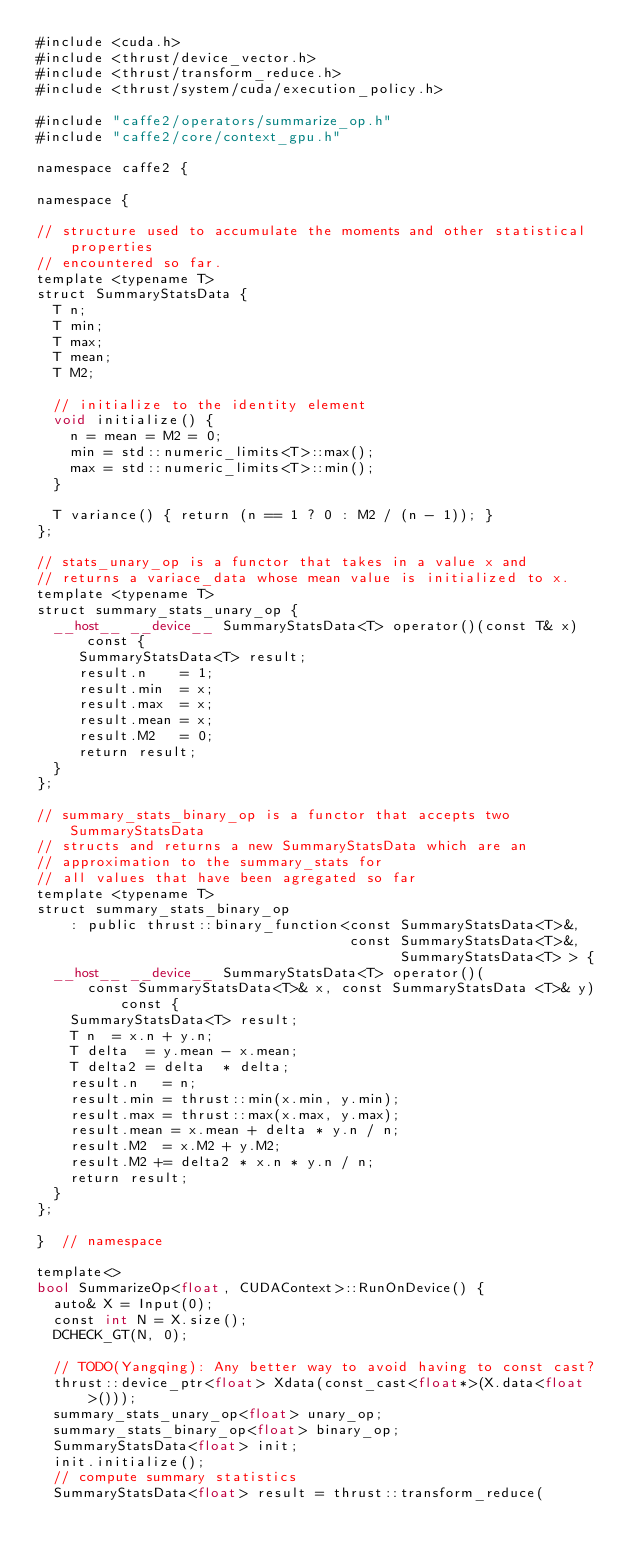<code> <loc_0><loc_0><loc_500><loc_500><_Cuda_>#include <cuda.h>
#include <thrust/device_vector.h>
#include <thrust/transform_reduce.h>
#include <thrust/system/cuda/execution_policy.h>

#include "caffe2/operators/summarize_op.h"
#include "caffe2/core/context_gpu.h"

namespace caffe2 {

namespace {

// structure used to accumulate the moments and other statistical properties
// encountered so far.
template <typename T>
struct SummaryStatsData {
  T n;
  T min;
  T max;
  T mean;
  T M2;

  // initialize to the identity element
  void initialize() {
    n = mean = M2 = 0;
    min = std::numeric_limits<T>::max();
    max = std::numeric_limits<T>::min();
  }

  T variance() { return (n == 1 ? 0 : M2 / (n - 1)); }
};

// stats_unary_op is a functor that takes in a value x and
// returns a variace_data whose mean value is initialized to x.
template <typename T>
struct summary_stats_unary_op {
  __host__ __device__ SummaryStatsData<T> operator()(const T& x) const {
     SummaryStatsData<T> result;
     result.n    = 1;
     result.min  = x;
     result.max  = x;
     result.mean = x;
     result.M2   = 0;
     return result;
  }
};

// summary_stats_binary_op is a functor that accepts two SummaryStatsData
// structs and returns a new SummaryStatsData which are an
// approximation to the summary_stats for
// all values that have been agregated so far
template <typename T>
struct summary_stats_binary_op
    : public thrust::binary_function<const SummaryStatsData<T>&,
                                     const SummaryStatsData<T>&,
                                           SummaryStatsData<T> > {
  __host__ __device__ SummaryStatsData<T> operator()(
      const SummaryStatsData<T>& x, const SummaryStatsData <T>& y) const {
    SummaryStatsData<T> result;
    T n  = x.n + y.n;
    T delta  = y.mean - x.mean;
    T delta2 = delta  * delta;
    result.n   = n;
    result.min = thrust::min(x.min, y.min);
    result.max = thrust::max(x.max, y.max);
    result.mean = x.mean + delta * y.n / n;
    result.M2  = x.M2 + y.M2;
    result.M2 += delta2 * x.n * y.n / n;
    return result;
  }
};

}  // namespace

template<>
bool SummarizeOp<float, CUDAContext>::RunOnDevice() {
  auto& X = Input(0);
  const int N = X.size();
  DCHECK_GT(N, 0);

  // TODO(Yangqing): Any better way to avoid having to const cast?
  thrust::device_ptr<float> Xdata(const_cast<float*>(X.data<float>()));
  summary_stats_unary_op<float> unary_op;
  summary_stats_binary_op<float> binary_op;
  SummaryStatsData<float> init;
  init.initialize();
  // compute summary statistics
  SummaryStatsData<float> result = thrust::transform_reduce(</code> 